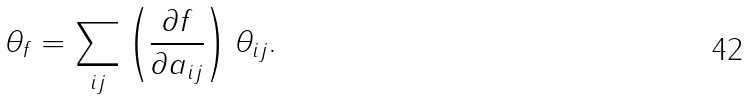Convert formula to latex. <formula><loc_0><loc_0><loc_500><loc_500>\theta _ { f } = \sum _ { i j } \left ( \frac { \partial f } { \partial a _ { i j } } \right ) \theta _ { i j } .</formula> 